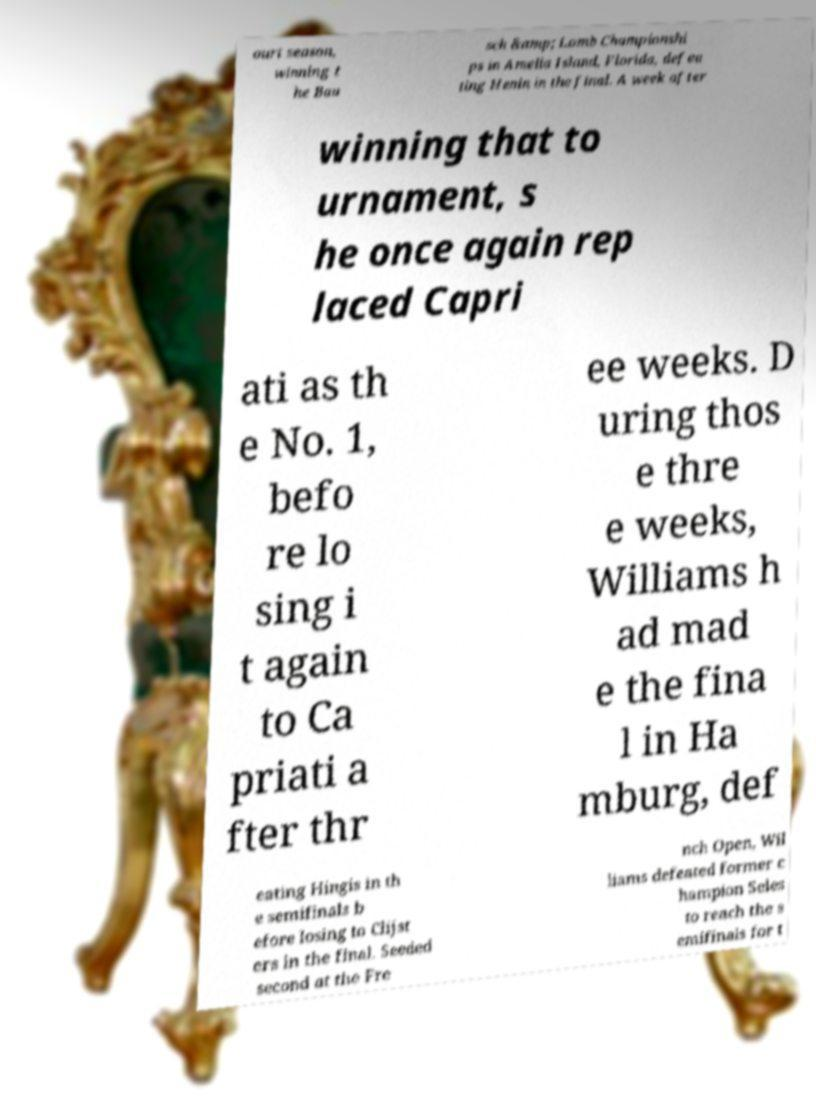What messages or text are displayed in this image? I need them in a readable, typed format. ourt season, winning t he Bau sch &amp; Lomb Championshi ps in Amelia Island, Florida, defea ting Henin in the final. A week after winning that to urnament, s he once again rep laced Capri ati as th e No. 1, befo re lo sing i t again to Ca priati a fter thr ee weeks. D uring thos e thre e weeks, Williams h ad mad e the fina l in Ha mburg, def eating Hingis in th e semifinals b efore losing to Clijst ers in the final. Seeded second at the Fre nch Open, Wil liams defeated former c hampion Seles to reach the s emifinals for t 